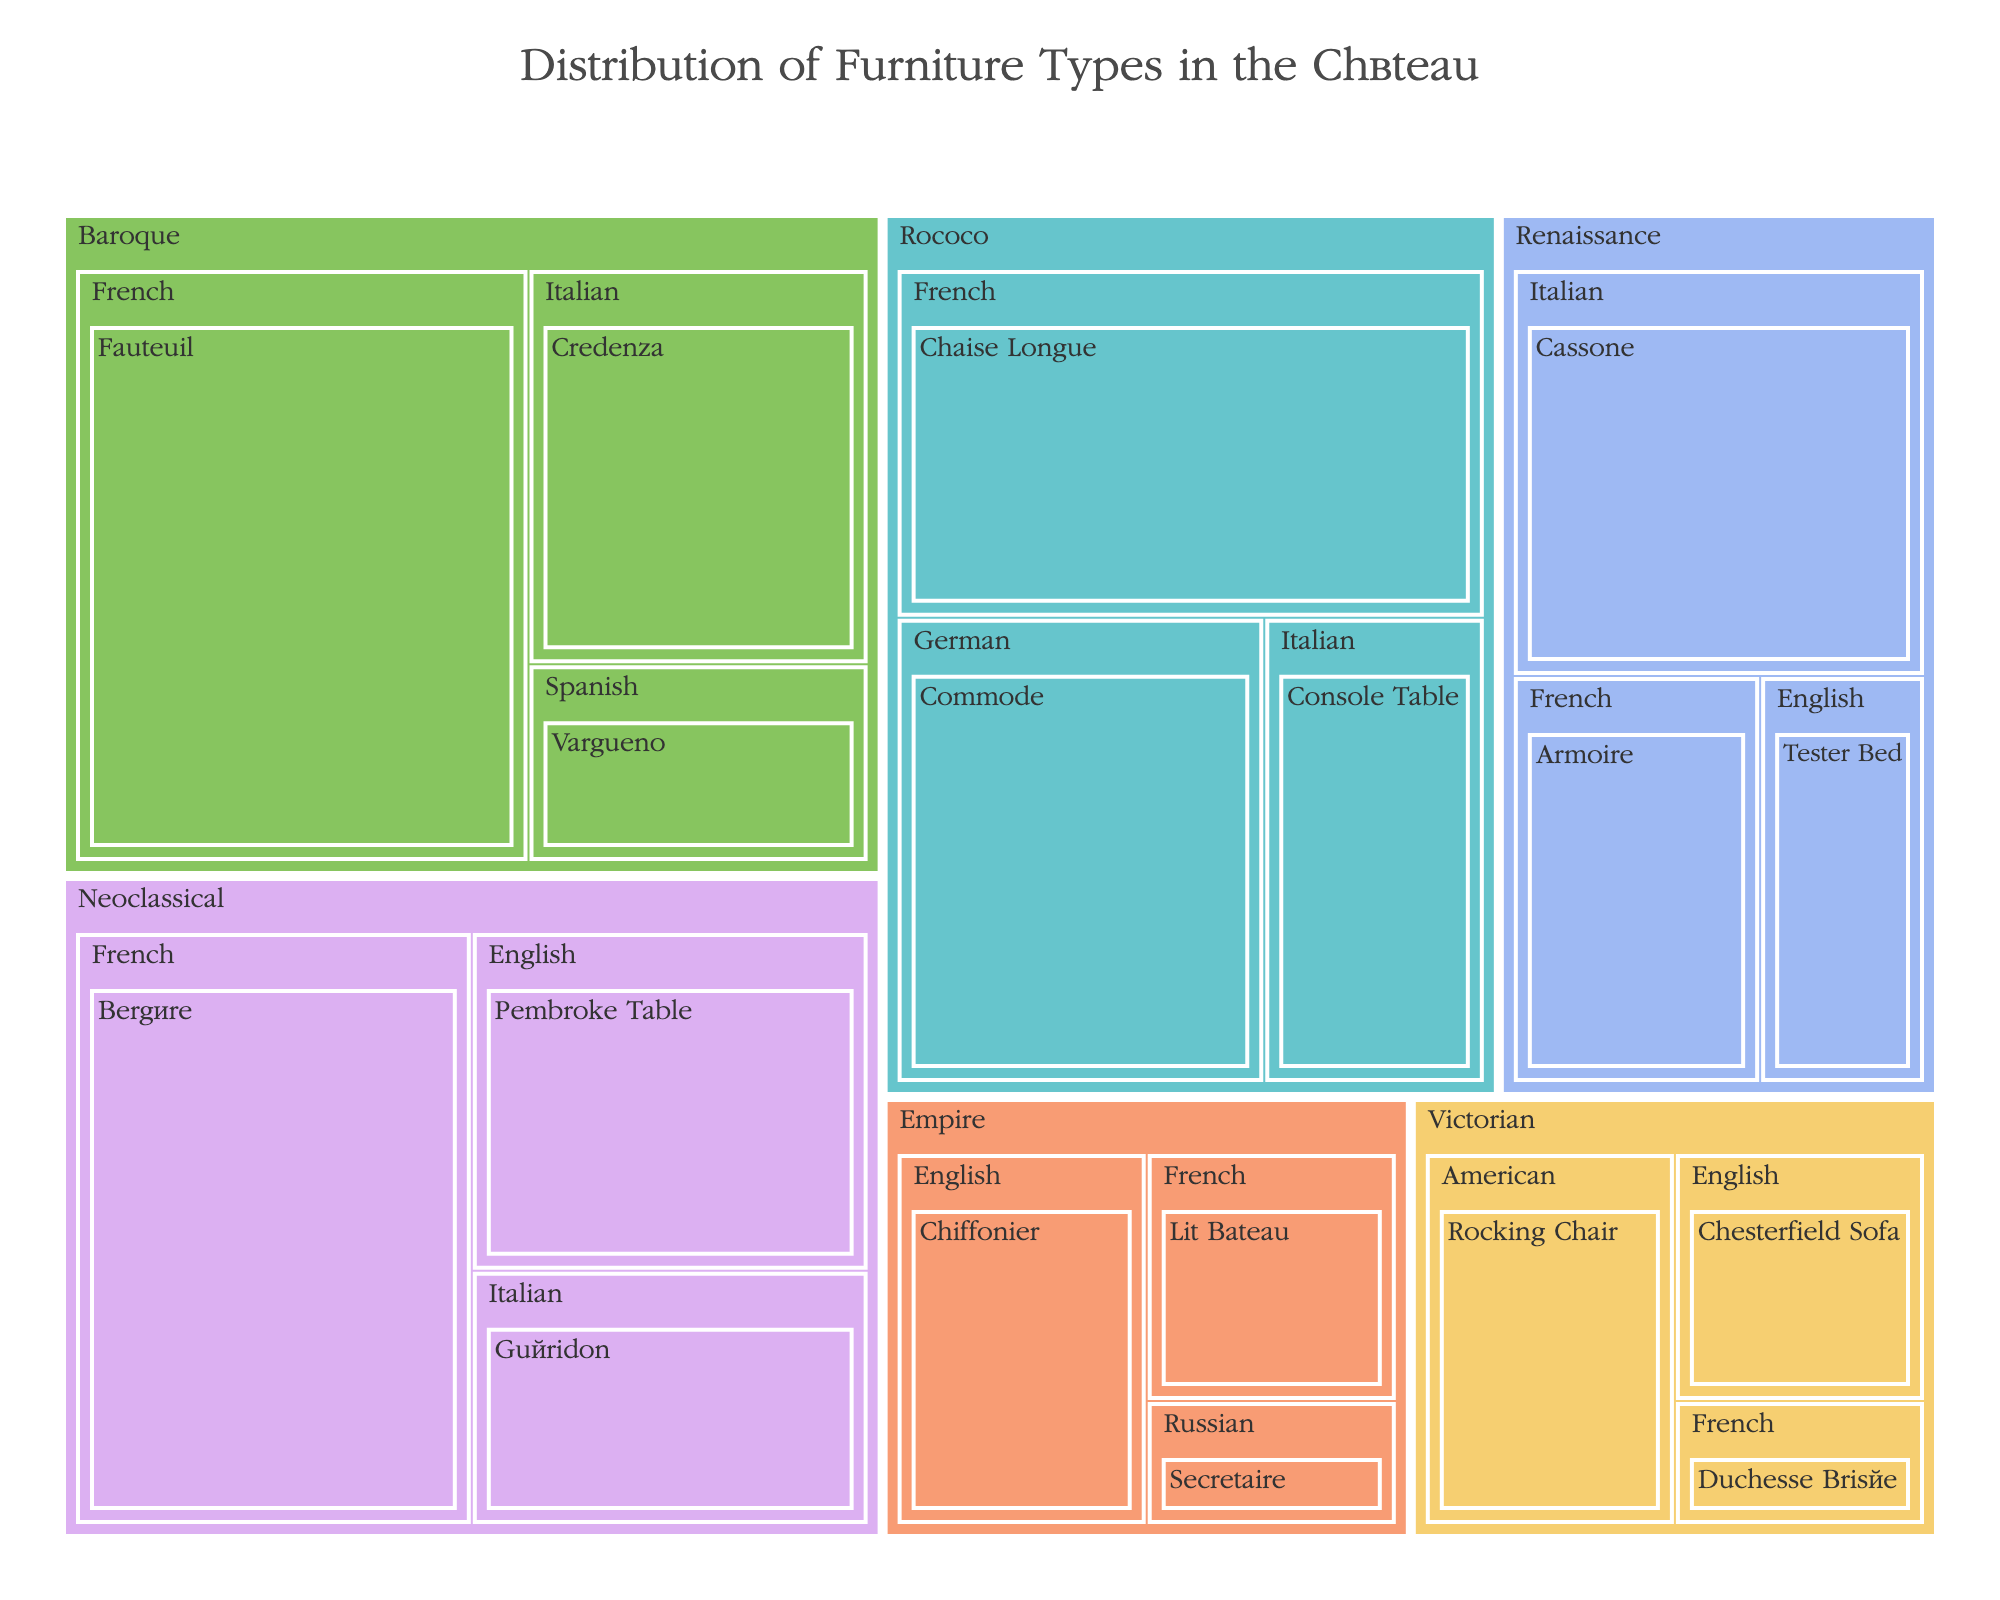What is the total quantity of Renaissance furniture pieces in the château? The treemap categorizes the furniture by era and style. Sum the quantities for each Renaissance furniture type: Cassone (5), Armoire (3), and Tester Bed (2). The total is 5 + 3 + 2 = 10.
Answer: 10 Which style within the Rococo era has the highest quantity of furniture pieces? Observe the Rococo era section of the treemap and compare quantities for each style. The French style has 6 (Chaise Longue), German has 5 (Commode), and Italian has 3 (Console Table). The French style has the highest quantity.
Answer: French What is the most common type of furniture in the Neoclassical era? Within the Neoclassical section, compare the quantities of each furniture type. Bergère (French) has 7, Pembroke Table (English) has 4, and Guéridon (Italian) has 3. Bergère is the most common.
Answer: Bergère How does the total quantity of Baroque furniture compare to that of Empire furniture? Sum the quantities for Baroque (Fauteuil: 8, Credenza: 4, Vargueno: 2) and Empire (Lit Bateau: 2, Chiffonier: 3, Secretaire: 1). Baroque total is 8 + 4 + 2 = 14. Empire total is 2 + 3 + 1 = 6. The Baroque era has more furniture pieces.
Answer: Baroque has more Which era has the smallest total quantity of furniture pieces? Compare the total quantities of each era. Calculate as follows: Renaissance (10), Baroque (14), Rococo (14), Neoclassical (14), Empire (6), Victorian (6). The Empire era has the smallest quantity.
Answer: Empire How many more pieces of French furniture does the Baroque era have compared to the Victorian era? In the Baroque era, French furniture (Fauteuil) has 8 pieces. In the Victorian era, French furniture (Duchesse Brisée) has 1 piece. The difference is 8 - 1 = 7 pieces.
Answer: 7 What is the average quantity of furniture types in the Rococo era? Sum the quantities of Rococo furniture types (Chaise Longue: 6, Commode: 5, Console Table: 3) and divide by the number of types. Total = 6 + 5 + 3 = 14. There are 3 types, so the average is 14 / 3 ≈ 4.67
Answer: 4.67 Which style within the Baroque era has the least quantity of furniture pieces? Observe the Baroque era section and compare the quantities for each style: French (8), Italian (4), Spanish (2). Spanish (Vargueno) has the least quantity.
Answer: Spanish 